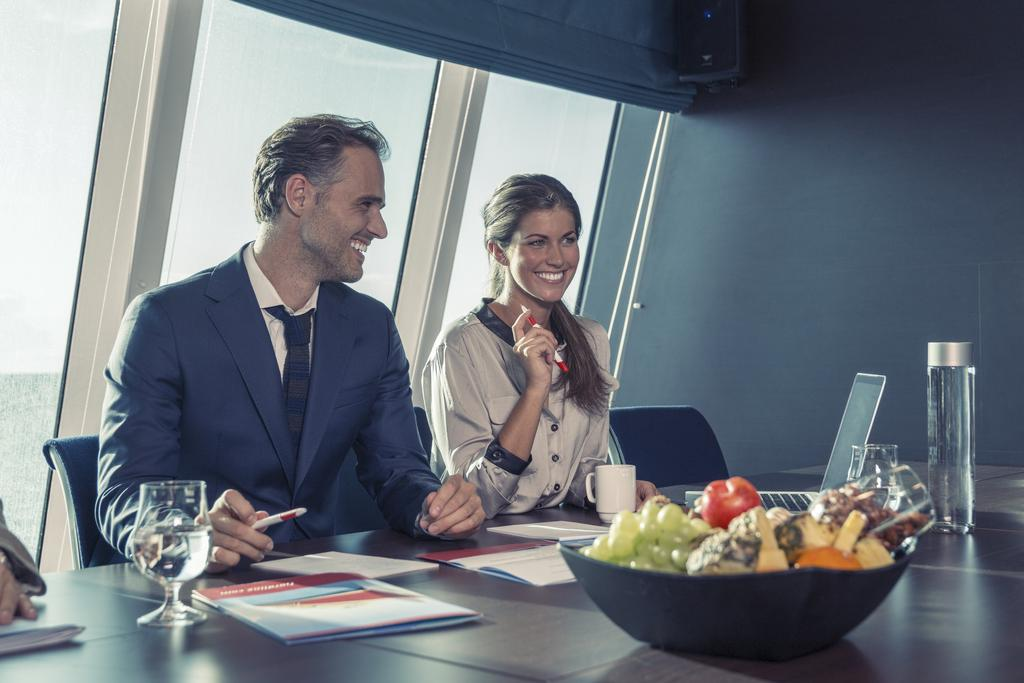Who is present in the image? There is a man and a woman in the image. What are they doing in the image? Both the man and the woman are sitting on chairs. How do they appear in the image? They both have smiles on their faces. What objects can be seen on the table in the image? There is a bottle, a glass, a mug, and papers on the table. What type of sheep can be seen wearing a veil in the image? There are no sheep or veils present in the image; it features a man and a woman sitting on chairs with smiles on their faces. Is there a notebook visible on the table in the image? No, there is no notebook present on the table in the image. 